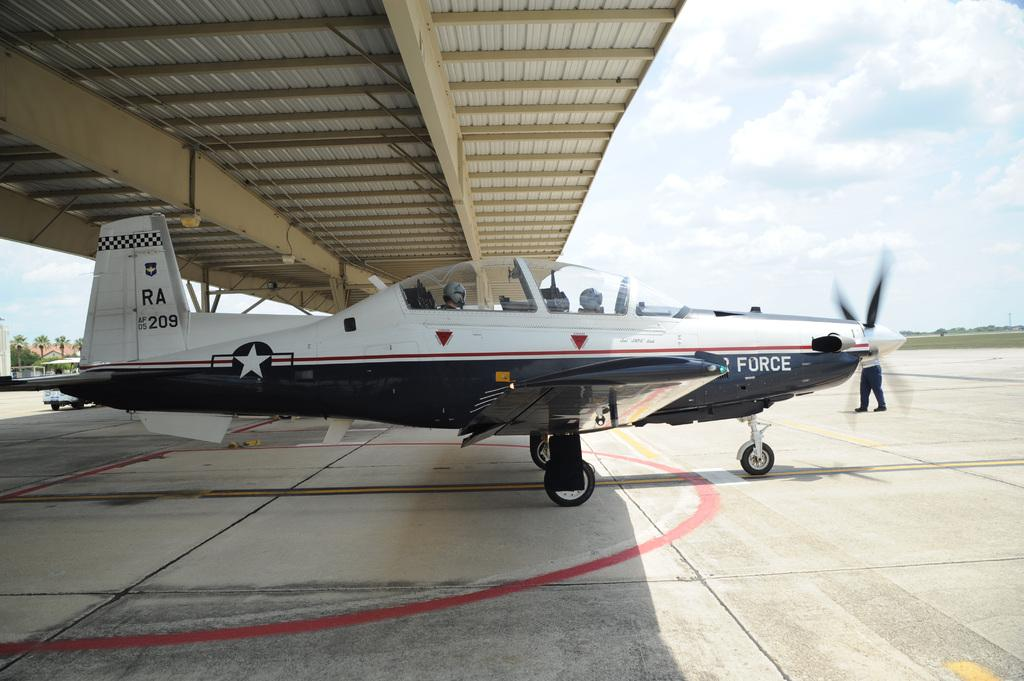<image>
Present a compact description of the photo's key features. Air force plane number RA 209 is on the tarmac underneath a bridge. 